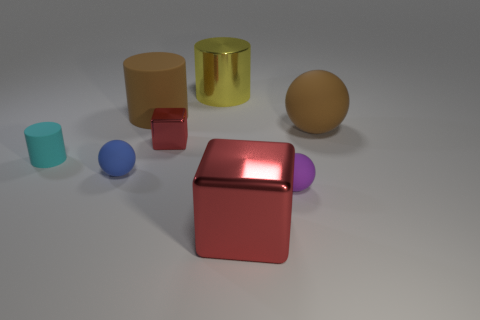What is the cyan cylinder made of?
Keep it short and to the point. Rubber. What shape is the tiny red shiny thing that is right of the cylinder that is in front of the large rubber object that is right of the small red shiny thing?
Provide a succinct answer. Cube. Is the number of small purple matte balls in front of the big ball greater than the number of green matte cylinders?
Offer a terse response. Yes. There is a tiny red object; is it the same shape as the red shiny object in front of the tiny rubber cylinder?
Provide a short and direct response. Yes. What shape is the object that is the same color as the big sphere?
Offer a very short reply. Cylinder. There is a cube that is to the left of the big metal object that is behind the large brown rubber ball; what number of tiny red cubes are on the right side of it?
Give a very brief answer. 0. What is the color of the metallic block that is the same size as the yellow cylinder?
Provide a succinct answer. Red. There is a brown thing right of the red shiny cube right of the yellow metallic cylinder; what size is it?
Your answer should be compact. Large. There is a object that is the same color as the big ball; what size is it?
Offer a terse response. Large. How many other things are the same size as the yellow metallic cylinder?
Provide a succinct answer. 3. 